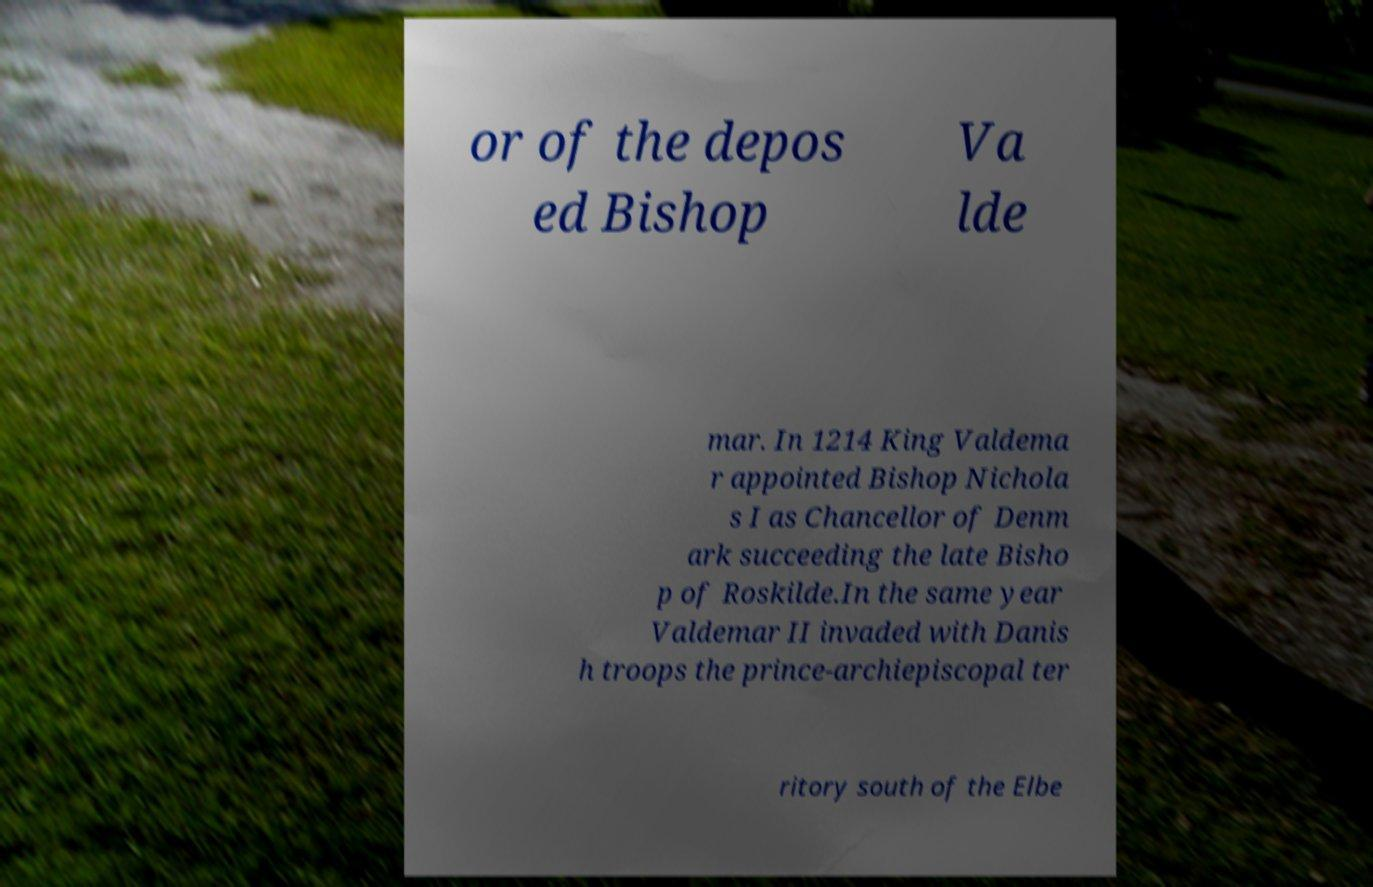What messages or text are displayed in this image? I need them in a readable, typed format. or of the depos ed Bishop Va lde mar. In 1214 King Valdema r appointed Bishop Nichola s I as Chancellor of Denm ark succeeding the late Bisho p of Roskilde.In the same year Valdemar II invaded with Danis h troops the prince-archiepiscopal ter ritory south of the Elbe 